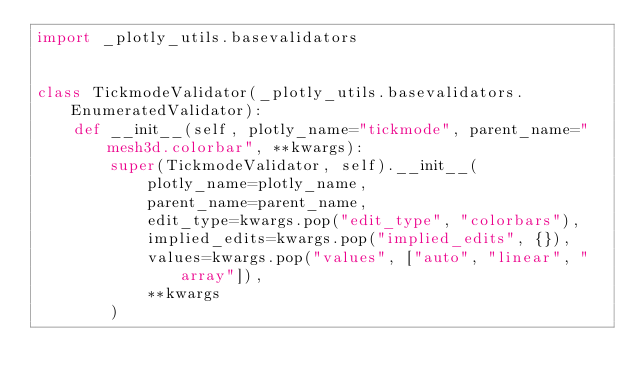Convert code to text. <code><loc_0><loc_0><loc_500><loc_500><_Python_>import _plotly_utils.basevalidators


class TickmodeValidator(_plotly_utils.basevalidators.EnumeratedValidator):
    def __init__(self, plotly_name="tickmode", parent_name="mesh3d.colorbar", **kwargs):
        super(TickmodeValidator, self).__init__(
            plotly_name=plotly_name,
            parent_name=parent_name,
            edit_type=kwargs.pop("edit_type", "colorbars"),
            implied_edits=kwargs.pop("implied_edits", {}),
            values=kwargs.pop("values", ["auto", "linear", "array"]),
            **kwargs
        )
</code> 